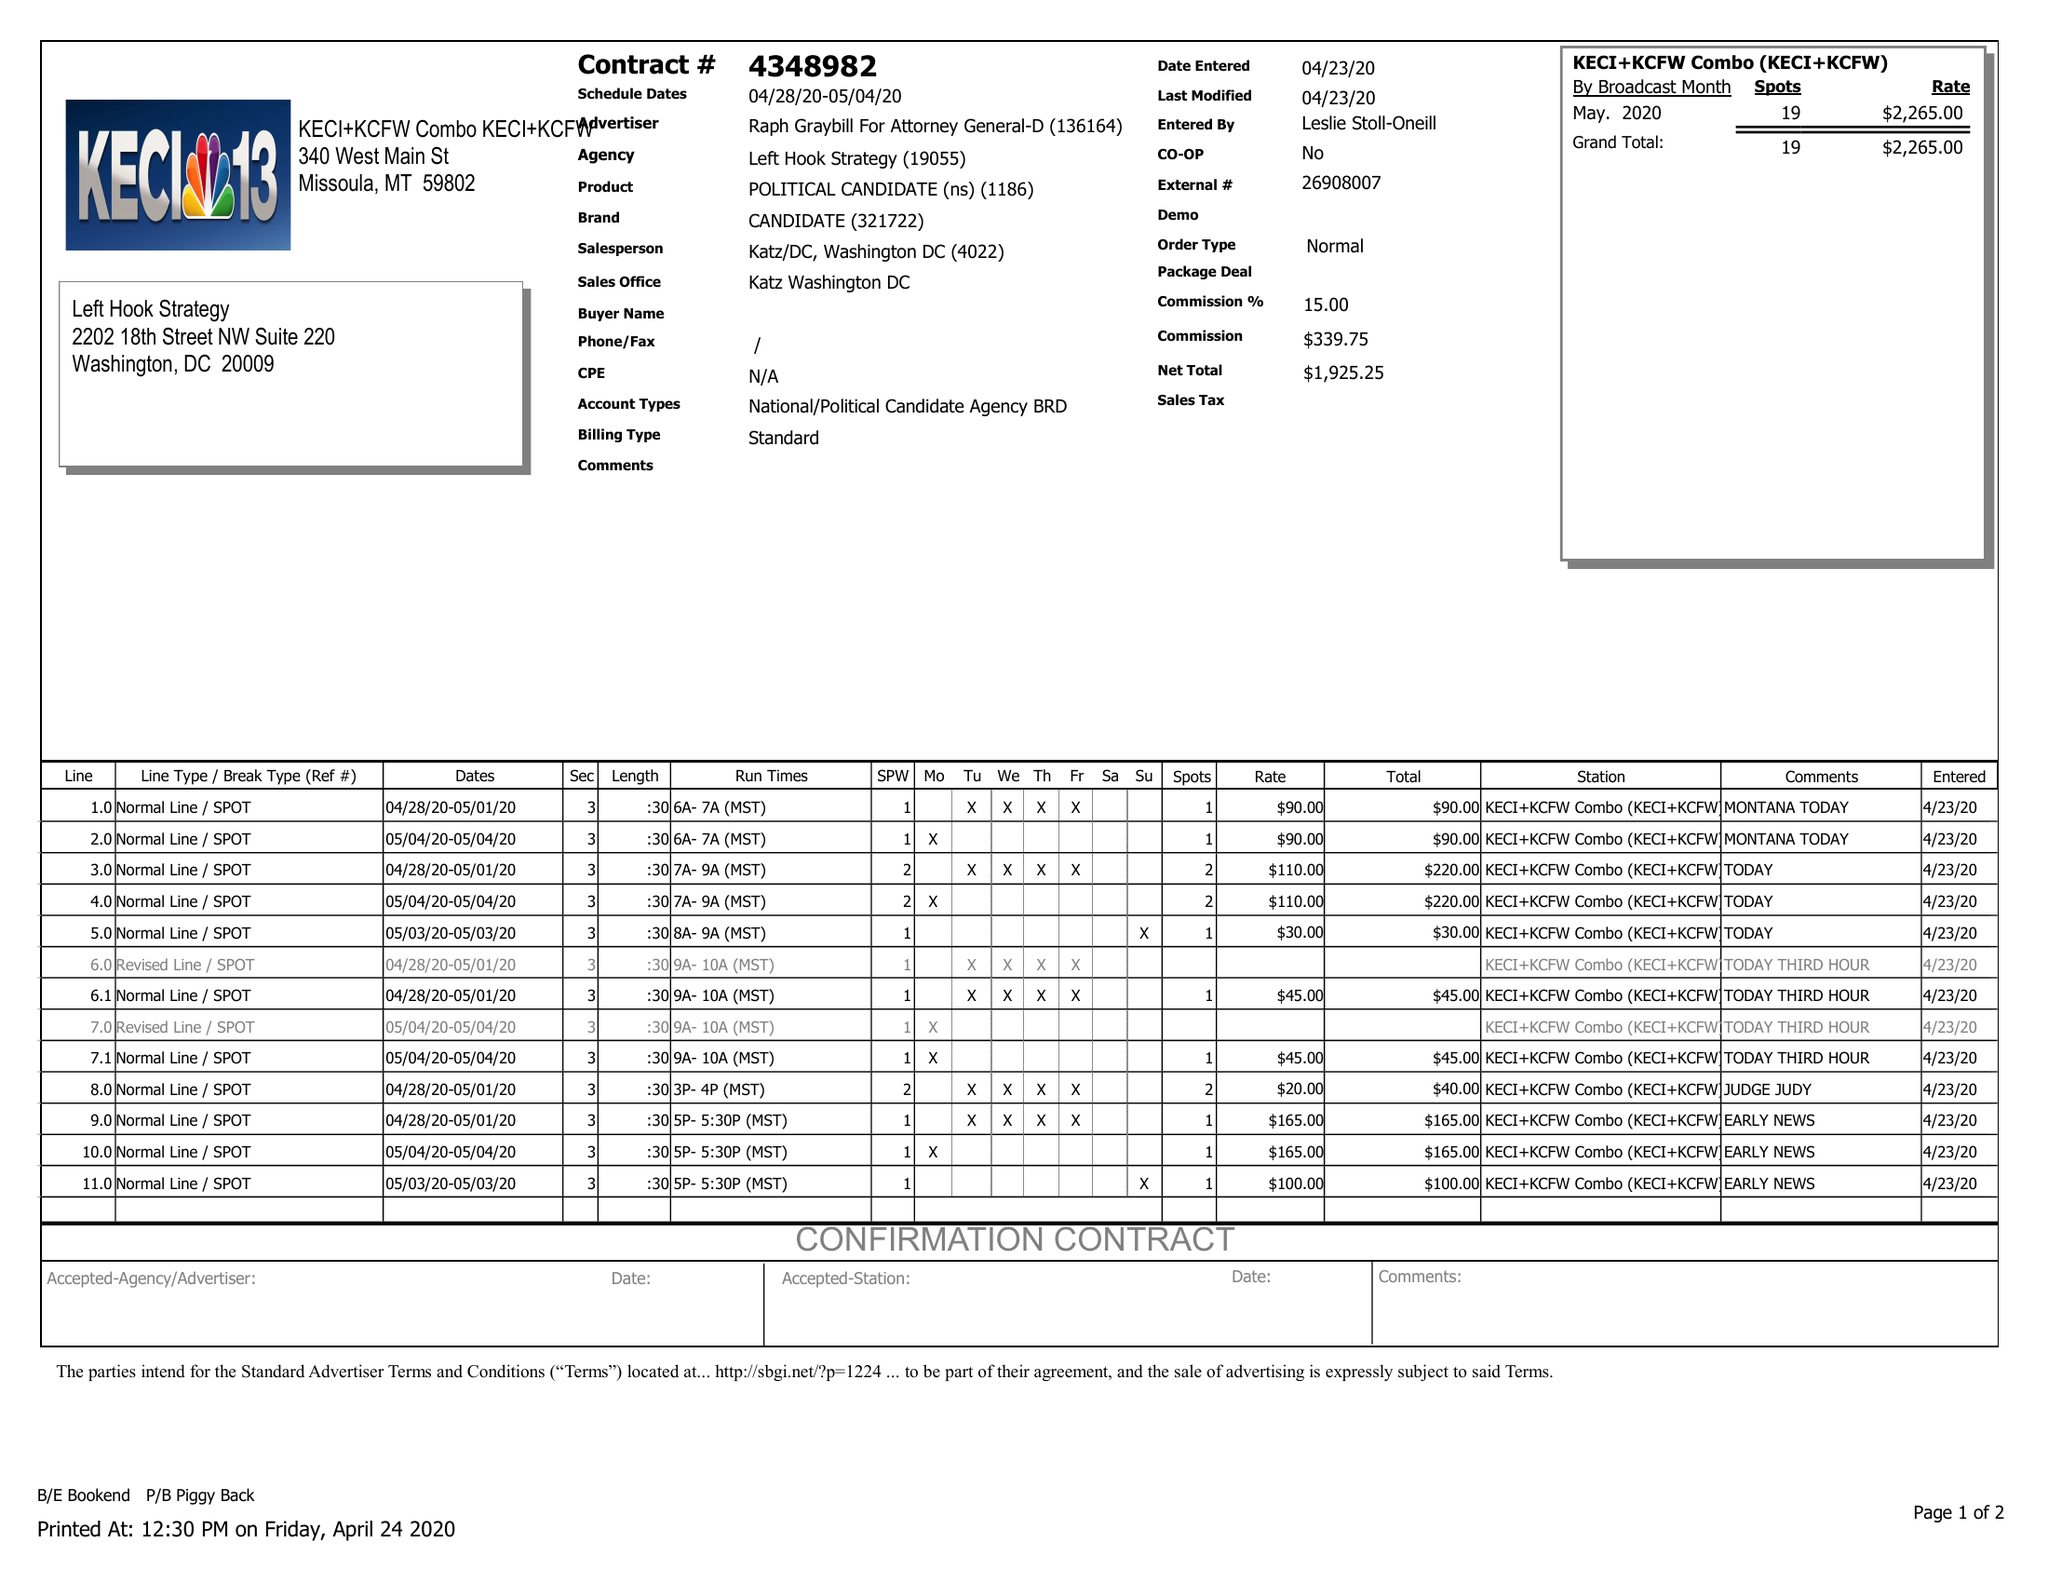What is the value for the advertiser?
Answer the question using a single word or phrase. RAPH GRAYBILL FOR ATTORNEY GENERAL-D 